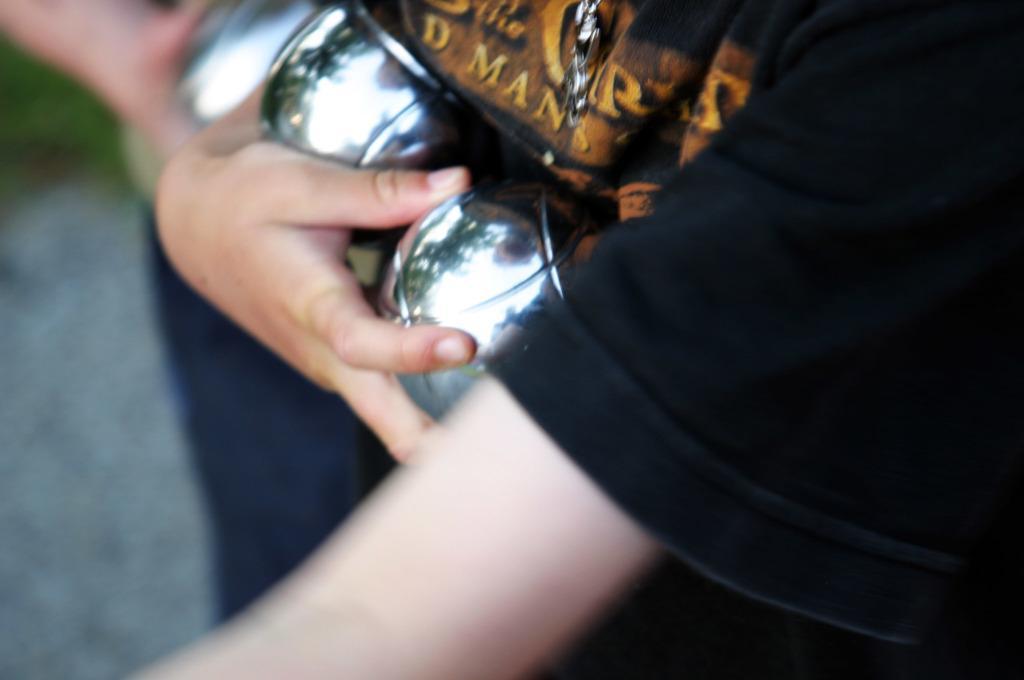In one or two sentences, can you explain what this image depicts? In this picture I can see 2 persons who are holding silver color things in their hands and I see that this image is a bit blurry. 